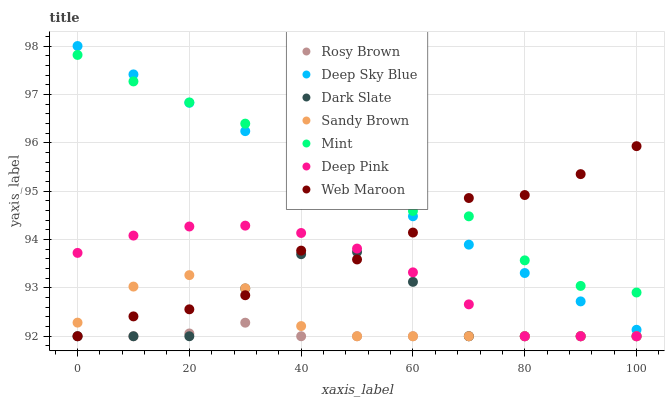Does Rosy Brown have the minimum area under the curve?
Answer yes or no. Yes. Does Mint have the maximum area under the curve?
Answer yes or no. Yes. Does Mint have the minimum area under the curve?
Answer yes or no. No. Does Rosy Brown have the maximum area under the curve?
Answer yes or no. No. Is Deep Sky Blue the smoothest?
Answer yes or no. Yes. Is Dark Slate the roughest?
Answer yes or no. Yes. Is Mint the smoothest?
Answer yes or no. No. Is Mint the roughest?
Answer yes or no. No. Does Deep Pink have the lowest value?
Answer yes or no. Yes. Does Mint have the lowest value?
Answer yes or no. No. Does Deep Sky Blue have the highest value?
Answer yes or no. Yes. Does Mint have the highest value?
Answer yes or no. No. Is Dark Slate less than Mint?
Answer yes or no. Yes. Is Deep Sky Blue greater than Sandy Brown?
Answer yes or no. Yes. Does Mint intersect Deep Sky Blue?
Answer yes or no. Yes. Is Mint less than Deep Sky Blue?
Answer yes or no. No. Is Mint greater than Deep Sky Blue?
Answer yes or no. No. Does Dark Slate intersect Mint?
Answer yes or no. No. 